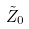<formula> <loc_0><loc_0><loc_500><loc_500>\tilde { Z } _ { 0 }</formula> 